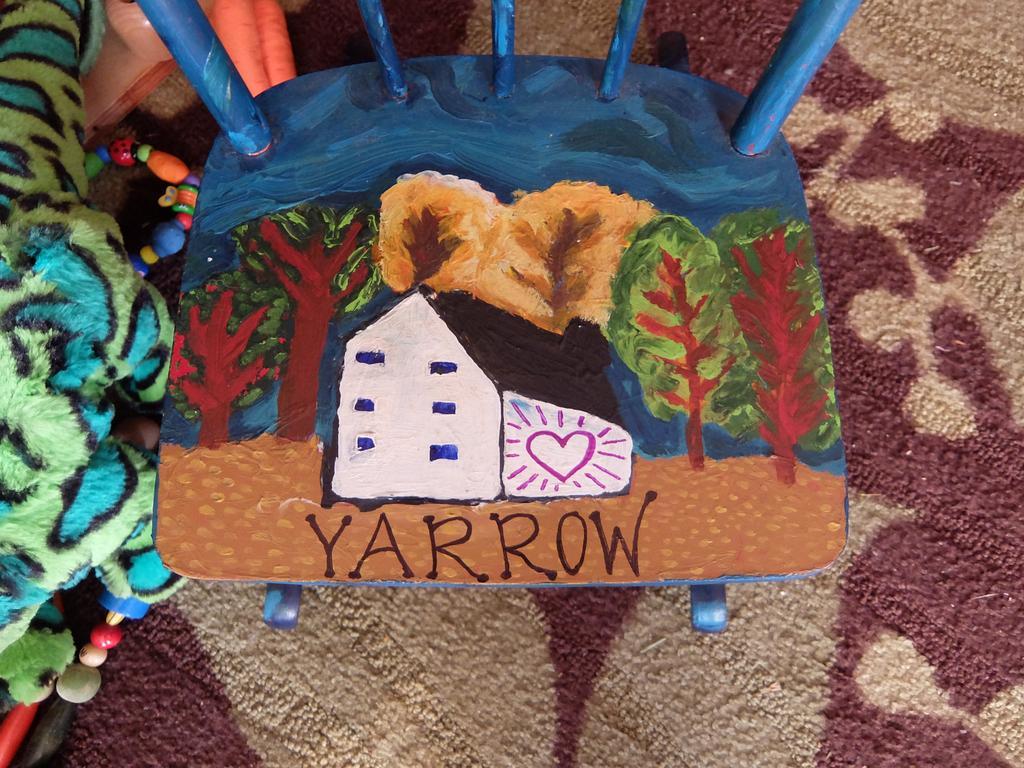Could you give a brief overview of what you see in this image? In this image I can see a blue color thing and on it I can see painting of a house, trees and I can also see something is written over here. On left side of this image I can see a green color thing. 